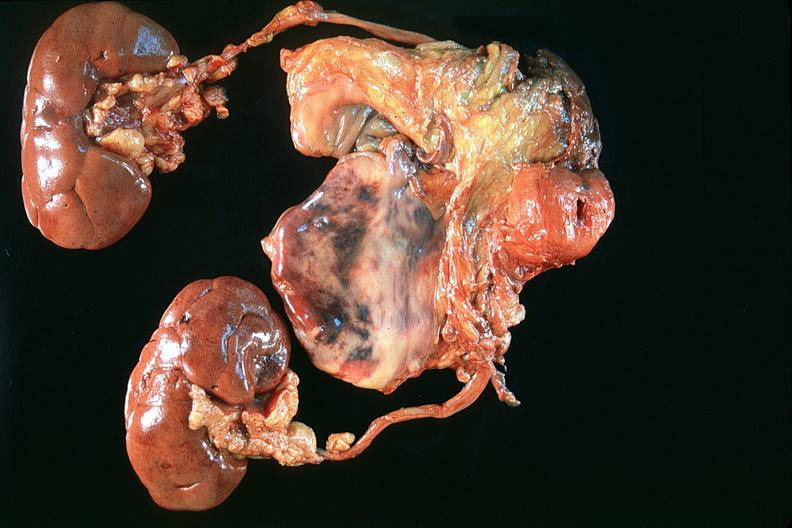what does this image show?
Answer the question using a single word or phrase. Normal prostate 